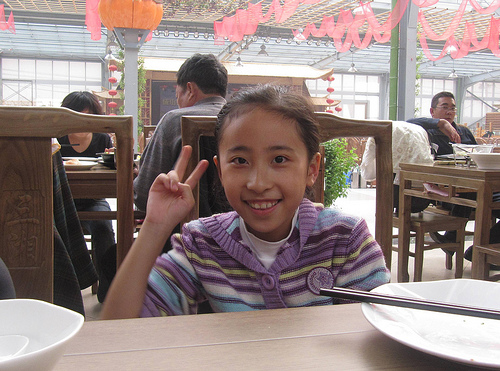<image>
Is there a girl on the chair? No. The girl is not positioned on the chair. They may be near each other, but the girl is not supported by or resting on top of the chair. 